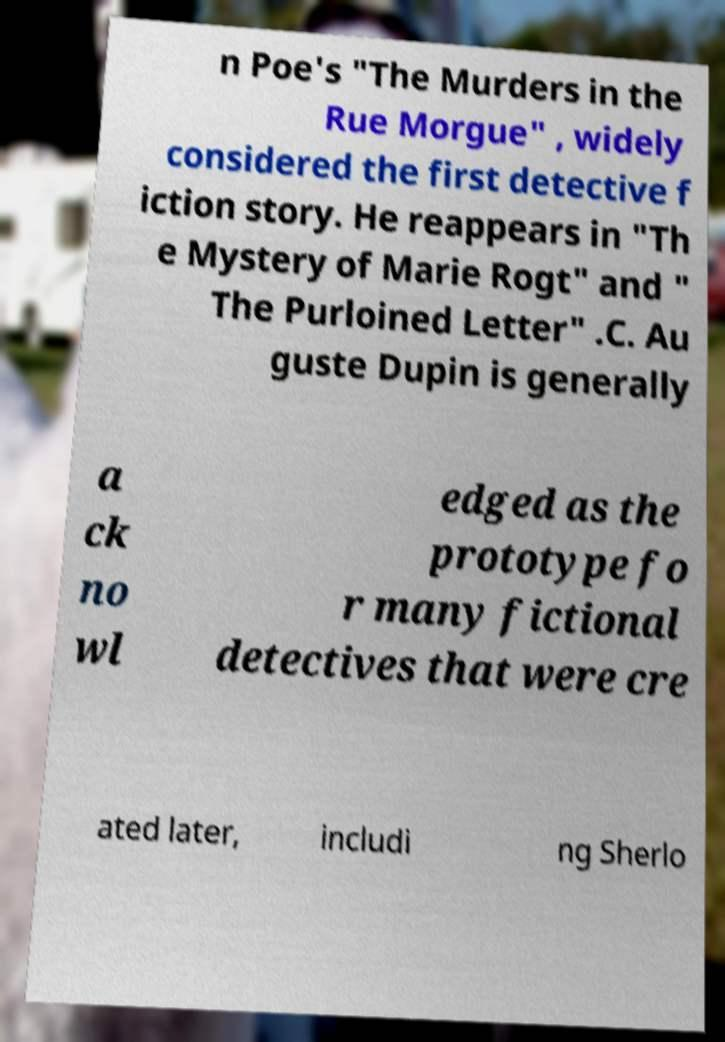Please identify and transcribe the text found in this image. n Poe's "The Murders in the Rue Morgue" , widely considered the first detective f iction story. He reappears in "Th e Mystery of Marie Rogt" and " The Purloined Letter" .C. Au guste Dupin is generally a ck no wl edged as the prototype fo r many fictional detectives that were cre ated later, includi ng Sherlo 